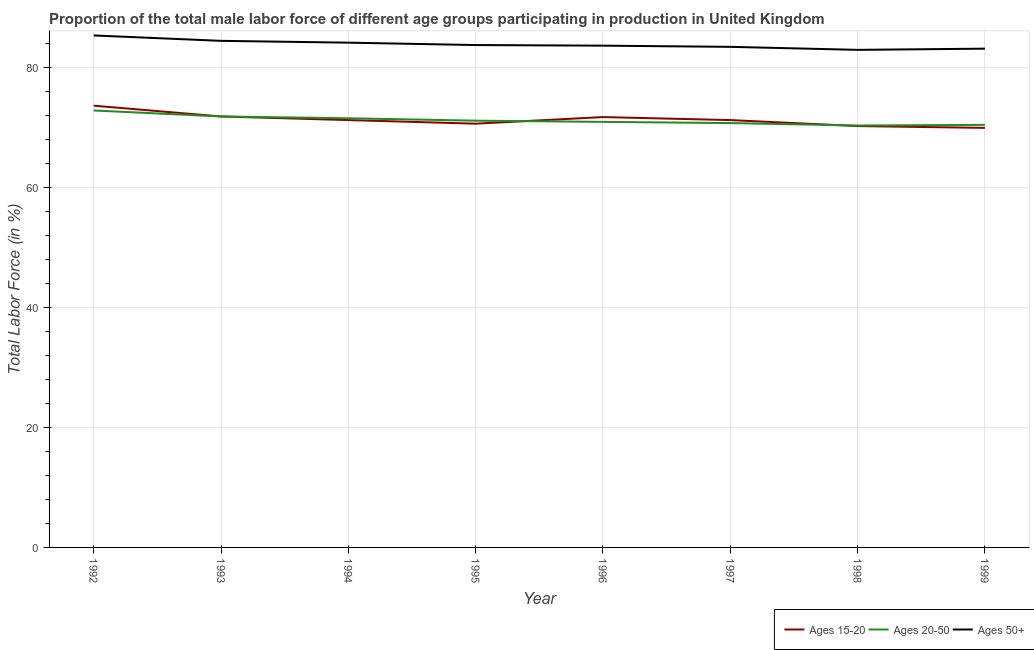Does the line corresponding to percentage of male labor force within the age group 20-50 intersect with the line corresponding to percentage of male labor force above age 50?
Your answer should be compact. No. Is the number of lines equal to the number of legend labels?
Make the answer very short. Yes. What is the percentage of male labor force above age 50 in 1994?
Your answer should be very brief. 84.1. Across all years, what is the maximum percentage of male labor force within the age group 20-50?
Your answer should be compact. 72.8. Across all years, what is the minimum percentage of male labor force within the age group 15-20?
Make the answer very short. 69.9. In which year was the percentage of male labor force above age 50 maximum?
Give a very brief answer. 1992. In which year was the percentage of male labor force above age 50 minimum?
Your response must be concise. 1998. What is the total percentage of male labor force above age 50 in the graph?
Ensure brevity in your answer.  670.5. What is the difference between the percentage of male labor force above age 50 in 1996 and that in 1998?
Provide a short and direct response. 0.7. What is the average percentage of male labor force within the age group 15-20 per year?
Your answer should be compact. 71.27. In the year 1993, what is the difference between the percentage of male labor force within the age group 15-20 and percentage of male labor force above age 50?
Provide a short and direct response. -12.6. In how many years, is the percentage of male labor force within the age group 20-50 greater than 16 %?
Give a very brief answer. 8. What is the ratio of the percentage of male labor force within the age group 15-20 in 1996 to that in 1997?
Your answer should be compact. 1.01. Is the difference between the percentage of male labor force within the age group 20-50 in 1994 and 1995 greater than the difference between the percentage of male labor force within the age group 15-20 in 1994 and 1995?
Provide a succinct answer. No. What is the difference between the highest and the second highest percentage of male labor force within the age group 20-50?
Offer a terse response. 1. What is the difference between the highest and the lowest percentage of male labor force within the age group 15-20?
Offer a very short reply. 3.7. How many lines are there?
Offer a terse response. 3. How many years are there in the graph?
Offer a terse response. 8. What is the difference between two consecutive major ticks on the Y-axis?
Give a very brief answer. 20. Are the values on the major ticks of Y-axis written in scientific E-notation?
Make the answer very short. No. Does the graph contain grids?
Ensure brevity in your answer.  Yes. How many legend labels are there?
Your response must be concise. 3. How are the legend labels stacked?
Ensure brevity in your answer.  Horizontal. What is the title of the graph?
Ensure brevity in your answer.  Proportion of the total male labor force of different age groups participating in production in United Kingdom. What is the Total Labor Force (in %) of Ages 15-20 in 1992?
Your answer should be compact. 73.6. What is the Total Labor Force (in %) of Ages 20-50 in 1992?
Your response must be concise. 72.8. What is the Total Labor Force (in %) in Ages 50+ in 1992?
Your answer should be compact. 85.3. What is the Total Labor Force (in %) in Ages 15-20 in 1993?
Your answer should be compact. 71.8. What is the Total Labor Force (in %) in Ages 20-50 in 1993?
Offer a terse response. 71.8. What is the Total Labor Force (in %) of Ages 50+ in 1993?
Your answer should be very brief. 84.4. What is the Total Labor Force (in %) in Ages 15-20 in 1994?
Make the answer very short. 71.2. What is the Total Labor Force (in %) in Ages 20-50 in 1994?
Your answer should be compact. 71.5. What is the Total Labor Force (in %) of Ages 50+ in 1994?
Your answer should be very brief. 84.1. What is the Total Labor Force (in %) of Ages 15-20 in 1995?
Provide a succinct answer. 70.6. What is the Total Labor Force (in %) of Ages 20-50 in 1995?
Provide a succinct answer. 71.1. What is the Total Labor Force (in %) of Ages 50+ in 1995?
Ensure brevity in your answer.  83.7. What is the Total Labor Force (in %) of Ages 15-20 in 1996?
Make the answer very short. 71.7. What is the Total Labor Force (in %) of Ages 20-50 in 1996?
Offer a terse response. 70.9. What is the Total Labor Force (in %) in Ages 50+ in 1996?
Your answer should be compact. 83.6. What is the Total Labor Force (in %) of Ages 15-20 in 1997?
Ensure brevity in your answer.  71.2. What is the Total Labor Force (in %) in Ages 20-50 in 1997?
Give a very brief answer. 70.7. What is the Total Labor Force (in %) of Ages 50+ in 1997?
Ensure brevity in your answer.  83.4. What is the Total Labor Force (in %) in Ages 15-20 in 1998?
Provide a short and direct response. 70.2. What is the Total Labor Force (in %) in Ages 20-50 in 1998?
Provide a succinct answer. 70.3. What is the Total Labor Force (in %) in Ages 50+ in 1998?
Provide a short and direct response. 82.9. What is the Total Labor Force (in %) of Ages 15-20 in 1999?
Your answer should be compact. 69.9. What is the Total Labor Force (in %) in Ages 20-50 in 1999?
Keep it short and to the point. 70.4. What is the Total Labor Force (in %) in Ages 50+ in 1999?
Give a very brief answer. 83.1. Across all years, what is the maximum Total Labor Force (in %) of Ages 15-20?
Give a very brief answer. 73.6. Across all years, what is the maximum Total Labor Force (in %) in Ages 20-50?
Make the answer very short. 72.8. Across all years, what is the maximum Total Labor Force (in %) of Ages 50+?
Offer a very short reply. 85.3. Across all years, what is the minimum Total Labor Force (in %) of Ages 15-20?
Offer a very short reply. 69.9. Across all years, what is the minimum Total Labor Force (in %) in Ages 20-50?
Your response must be concise. 70.3. Across all years, what is the minimum Total Labor Force (in %) in Ages 50+?
Provide a succinct answer. 82.9. What is the total Total Labor Force (in %) in Ages 15-20 in the graph?
Make the answer very short. 570.2. What is the total Total Labor Force (in %) in Ages 20-50 in the graph?
Offer a very short reply. 569.5. What is the total Total Labor Force (in %) in Ages 50+ in the graph?
Give a very brief answer. 670.5. What is the difference between the Total Labor Force (in %) in Ages 20-50 in 1992 and that in 1993?
Keep it short and to the point. 1. What is the difference between the Total Labor Force (in %) in Ages 50+ in 1992 and that in 1993?
Your answer should be very brief. 0.9. What is the difference between the Total Labor Force (in %) of Ages 15-20 in 1992 and that in 1994?
Make the answer very short. 2.4. What is the difference between the Total Labor Force (in %) of Ages 15-20 in 1992 and that in 1995?
Offer a very short reply. 3. What is the difference between the Total Labor Force (in %) of Ages 20-50 in 1992 and that in 1995?
Ensure brevity in your answer.  1.7. What is the difference between the Total Labor Force (in %) of Ages 50+ in 1992 and that in 1995?
Offer a terse response. 1.6. What is the difference between the Total Labor Force (in %) in Ages 15-20 in 1992 and that in 1996?
Offer a very short reply. 1.9. What is the difference between the Total Labor Force (in %) of Ages 20-50 in 1992 and that in 1996?
Ensure brevity in your answer.  1.9. What is the difference between the Total Labor Force (in %) in Ages 50+ in 1992 and that in 1996?
Make the answer very short. 1.7. What is the difference between the Total Labor Force (in %) of Ages 20-50 in 1992 and that in 1997?
Your answer should be very brief. 2.1. What is the difference between the Total Labor Force (in %) in Ages 50+ in 1992 and that in 1997?
Provide a succinct answer. 1.9. What is the difference between the Total Labor Force (in %) in Ages 15-20 in 1992 and that in 1998?
Ensure brevity in your answer.  3.4. What is the difference between the Total Labor Force (in %) of Ages 20-50 in 1992 and that in 1998?
Offer a very short reply. 2.5. What is the difference between the Total Labor Force (in %) in Ages 15-20 in 1992 and that in 1999?
Ensure brevity in your answer.  3.7. What is the difference between the Total Labor Force (in %) in Ages 50+ in 1993 and that in 1994?
Offer a very short reply. 0.3. What is the difference between the Total Labor Force (in %) of Ages 20-50 in 1993 and that in 1996?
Provide a succinct answer. 0.9. What is the difference between the Total Labor Force (in %) in Ages 50+ in 1993 and that in 1996?
Offer a terse response. 0.8. What is the difference between the Total Labor Force (in %) in Ages 15-20 in 1993 and that in 1997?
Make the answer very short. 0.6. What is the difference between the Total Labor Force (in %) in Ages 20-50 in 1993 and that in 1998?
Offer a very short reply. 1.5. What is the difference between the Total Labor Force (in %) in Ages 50+ in 1993 and that in 1998?
Your response must be concise. 1.5. What is the difference between the Total Labor Force (in %) of Ages 50+ in 1993 and that in 1999?
Give a very brief answer. 1.3. What is the difference between the Total Labor Force (in %) in Ages 15-20 in 1994 and that in 1995?
Your response must be concise. 0.6. What is the difference between the Total Labor Force (in %) in Ages 15-20 in 1994 and that in 1996?
Ensure brevity in your answer.  -0.5. What is the difference between the Total Labor Force (in %) of Ages 20-50 in 1994 and that in 1996?
Your answer should be very brief. 0.6. What is the difference between the Total Labor Force (in %) of Ages 15-20 in 1994 and that in 1997?
Make the answer very short. 0. What is the difference between the Total Labor Force (in %) in Ages 15-20 in 1994 and that in 1998?
Offer a terse response. 1. What is the difference between the Total Labor Force (in %) in Ages 20-50 in 1994 and that in 1998?
Offer a very short reply. 1.2. What is the difference between the Total Labor Force (in %) of Ages 50+ in 1994 and that in 1998?
Offer a very short reply. 1.2. What is the difference between the Total Labor Force (in %) of Ages 15-20 in 1994 and that in 1999?
Your response must be concise. 1.3. What is the difference between the Total Labor Force (in %) of Ages 50+ in 1994 and that in 1999?
Your answer should be very brief. 1. What is the difference between the Total Labor Force (in %) in Ages 15-20 in 1995 and that in 1997?
Offer a terse response. -0.6. What is the difference between the Total Labor Force (in %) of Ages 50+ in 1995 and that in 1998?
Your answer should be very brief. 0.8. What is the difference between the Total Labor Force (in %) in Ages 15-20 in 1996 and that in 1997?
Offer a terse response. 0.5. What is the difference between the Total Labor Force (in %) in Ages 15-20 in 1996 and that in 1998?
Offer a terse response. 1.5. What is the difference between the Total Labor Force (in %) in Ages 20-50 in 1996 and that in 1998?
Ensure brevity in your answer.  0.6. What is the difference between the Total Labor Force (in %) of Ages 15-20 in 1997 and that in 1998?
Provide a succinct answer. 1. What is the difference between the Total Labor Force (in %) of Ages 20-50 in 1997 and that in 1999?
Give a very brief answer. 0.3. What is the difference between the Total Labor Force (in %) in Ages 50+ in 1997 and that in 1999?
Your response must be concise. 0.3. What is the difference between the Total Labor Force (in %) of Ages 15-20 in 1998 and that in 1999?
Give a very brief answer. 0.3. What is the difference between the Total Labor Force (in %) in Ages 20-50 in 1998 and that in 1999?
Offer a very short reply. -0.1. What is the difference between the Total Labor Force (in %) of Ages 50+ in 1998 and that in 1999?
Give a very brief answer. -0.2. What is the difference between the Total Labor Force (in %) of Ages 15-20 in 1992 and the Total Labor Force (in %) of Ages 50+ in 1993?
Offer a very short reply. -10.8. What is the difference between the Total Labor Force (in %) in Ages 15-20 in 1992 and the Total Labor Force (in %) in Ages 20-50 in 1994?
Your response must be concise. 2.1. What is the difference between the Total Labor Force (in %) in Ages 20-50 in 1992 and the Total Labor Force (in %) in Ages 50+ in 1994?
Offer a terse response. -11.3. What is the difference between the Total Labor Force (in %) in Ages 20-50 in 1992 and the Total Labor Force (in %) in Ages 50+ in 1995?
Ensure brevity in your answer.  -10.9. What is the difference between the Total Labor Force (in %) in Ages 15-20 in 1992 and the Total Labor Force (in %) in Ages 20-50 in 1996?
Your answer should be very brief. 2.7. What is the difference between the Total Labor Force (in %) in Ages 20-50 in 1992 and the Total Labor Force (in %) in Ages 50+ in 1996?
Make the answer very short. -10.8. What is the difference between the Total Labor Force (in %) of Ages 15-20 in 1992 and the Total Labor Force (in %) of Ages 20-50 in 1997?
Offer a terse response. 2.9. What is the difference between the Total Labor Force (in %) in Ages 15-20 in 1992 and the Total Labor Force (in %) in Ages 50+ in 1997?
Your answer should be compact. -9.8. What is the difference between the Total Labor Force (in %) in Ages 20-50 in 1992 and the Total Labor Force (in %) in Ages 50+ in 1997?
Offer a terse response. -10.6. What is the difference between the Total Labor Force (in %) in Ages 15-20 in 1992 and the Total Labor Force (in %) in Ages 20-50 in 1998?
Give a very brief answer. 3.3. What is the difference between the Total Labor Force (in %) of Ages 15-20 in 1992 and the Total Labor Force (in %) of Ages 20-50 in 1999?
Give a very brief answer. 3.2. What is the difference between the Total Labor Force (in %) of Ages 15-20 in 1992 and the Total Labor Force (in %) of Ages 50+ in 1999?
Ensure brevity in your answer.  -9.5. What is the difference between the Total Labor Force (in %) in Ages 15-20 in 1993 and the Total Labor Force (in %) in Ages 50+ in 1994?
Your answer should be compact. -12.3. What is the difference between the Total Labor Force (in %) in Ages 20-50 in 1993 and the Total Labor Force (in %) in Ages 50+ in 1995?
Your answer should be compact. -11.9. What is the difference between the Total Labor Force (in %) of Ages 15-20 in 1993 and the Total Labor Force (in %) of Ages 20-50 in 1996?
Your answer should be very brief. 0.9. What is the difference between the Total Labor Force (in %) of Ages 15-20 in 1993 and the Total Labor Force (in %) of Ages 50+ in 1996?
Make the answer very short. -11.8. What is the difference between the Total Labor Force (in %) in Ages 15-20 in 1993 and the Total Labor Force (in %) in Ages 50+ in 1998?
Make the answer very short. -11.1. What is the difference between the Total Labor Force (in %) in Ages 15-20 in 1993 and the Total Labor Force (in %) in Ages 50+ in 1999?
Your answer should be compact. -11.3. What is the difference between the Total Labor Force (in %) of Ages 15-20 in 1994 and the Total Labor Force (in %) of Ages 50+ in 1995?
Give a very brief answer. -12.5. What is the difference between the Total Labor Force (in %) in Ages 20-50 in 1994 and the Total Labor Force (in %) in Ages 50+ in 1995?
Offer a terse response. -12.2. What is the difference between the Total Labor Force (in %) in Ages 15-20 in 1994 and the Total Labor Force (in %) in Ages 50+ in 1996?
Your response must be concise. -12.4. What is the difference between the Total Labor Force (in %) in Ages 20-50 in 1994 and the Total Labor Force (in %) in Ages 50+ in 1996?
Provide a succinct answer. -12.1. What is the difference between the Total Labor Force (in %) in Ages 15-20 in 1994 and the Total Labor Force (in %) in Ages 20-50 in 1997?
Your response must be concise. 0.5. What is the difference between the Total Labor Force (in %) of Ages 15-20 in 1994 and the Total Labor Force (in %) of Ages 50+ in 1998?
Offer a terse response. -11.7. What is the difference between the Total Labor Force (in %) of Ages 20-50 in 1994 and the Total Labor Force (in %) of Ages 50+ in 1998?
Offer a very short reply. -11.4. What is the difference between the Total Labor Force (in %) of Ages 15-20 in 1995 and the Total Labor Force (in %) of Ages 20-50 in 1996?
Offer a very short reply. -0.3. What is the difference between the Total Labor Force (in %) of Ages 15-20 in 1995 and the Total Labor Force (in %) of Ages 20-50 in 1997?
Offer a very short reply. -0.1. What is the difference between the Total Labor Force (in %) in Ages 15-20 in 1995 and the Total Labor Force (in %) in Ages 20-50 in 1998?
Keep it short and to the point. 0.3. What is the difference between the Total Labor Force (in %) of Ages 20-50 in 1995 and the Total Labor Force (in %) of Ages 50+ in 1999?
Make the answer very short. -12. What is the difference between the Total Labor Force (in %) in Ages 20-50 in 1996 and the Total Labor Force (in %) in Ages 50+ in 1998?
Your response must be concise. -12. What is the difference between the Total Labor Force (in %) in Ages 15-20 in 1996 and the Total Labor Force (in %) in Ages 20-50 in 1999?
Your answer should be compact. 1.3. What is the difference between the Total Labor Force (in %) of Ages 20-50 in 1997 and the Total Labor Force (in %) of Ages 50+ in 1998?
Your answer should be compact. -12.2. What is the difference between the Total Labor Force (in %) of Ages 15-20 in 1997 and the Total Labor Force (in %) of Ages 20-50 in 1999?
Offer a very short reply. 0.8. What is the difference between the Total Labor Force (in %) in Ages 20-50 in 1997 and the Total Labor Force (in %) in Ages 50+ in 1999?
Ensure brevity in your answer.  -12.4. What is the difference between the Total Labor Force (in %) of Ages 15-20 in 1998 and the Total Labor Force (in %) of Ages 20-50 in 1999?
Keep it short and to the point. -0.2. What is the difference between the Total Labor Force (in %) in Ages 15-20 in 1998 and the Total Labor Force (in %) in Ages 50+ in 1999?
Your response must be concise. -12.9. What is the difference between the Total Labor Force (in %) in Ages 20-50 in 1998 and the Total Labor Force (in %) in Ages 50+ in 1999?
Offer a terse response. -12.8. What is the average Total Labor Force (in %) of Ages 15-20 per year?
Provide a succinct answer. 71.28. What is the average Total Labor Force (in %) of Ages 20-50 per year?
Offer a terse response. 71.19. What is the average Total Labor Force (in %) in Ages 50+ per year?
Make the answer very short. 83.81. In the year 1992, what is the difference between the Total Labor Force (in %) in Ages 15-20 and Total Labor Force (in %) in Ages 50+?
Your answer should be very brief. -11.7. In the year 1992, what is the difference between the Total Labor Force (in %) of Ages 20-50 and Total Labor Force (in %) of Ages 50+?
Provide a short and direct response. -12.5. In the year 1993, what is the difference between the Total Labor Force (in %) in Ages 15-20 and Total Labor Force (in %) in Ages 20-50?
Your response must be concise. 0. In the year 1994, what is the difference between the Total Labor Force (in %) of Ages 15-20 and Total Labor Force (in %) of Ages 50+?
Offer a very short reply. -12.9. In the year 1995, what is the difference between the Total Labor Force (in %) of Ages 15-20 and Total Labor Force (in %) of Ages 50+?
Make the answer very short. -13.1. In the year 1996, what is the difference between the Total Labor Force (in %) in Ages 15-20 and Total Labor Force (in %) in Ages 50+?
Ensure brevity in your answer.  -11.9. In the year 1997, what is the difference between the Total Labor Force (in %) of Ages 15-20 and Total Labor Force (in %) of Ages 50+?
Provide a short and direct response. -12.2. In the year 1997, what is the difference between the Total Labor Force (in %) in Ages 20-50 and Total Labor Force (in %) in Ages 50+?
Give a very brief answer. -12.7. In the year 1998, what is the difference between the Total Labor Force (in %) of Ages 15-20 and Total Labor Force (in %) of Ages 50+?
Ensure brevity in your answer.  -12.7. In the year 1999, what is the difference between the Total Labor Force (in %) in Ages 15-20 and Total Labor Force (in %) in Ages 20-50?
Ensure brevity in your answer.  -0.5. In the year 1999, what is the difference between the Total Labor Force (in %) in Ages 15-20 and Total Labor Force (in %) in Ages 50+?
Offer a very short reply. -13.2. What is the ratio of the Total Labor Force (in %) of Ages 15-20 in 1992 to that in 1993?
Offer a very short reply. 1.03. What is the ratio of the Total Labor Force (in %) in Ages 20-50 in 1992 to that in 1993?
Offer a terse response. 1.01. What is the ratio of the Total Labor Force (in %) of Ages 50+ in 1992 to that in 1993?
Your answer should be very brief. 1.01. What is the ratio of the Total Labor Force (in %) in Ages 15-20 in 1992 to that in 1994?
Make the answer very short. 1.03. What is the ratio of the Total Labor Force (in %) of Ages 20-50 in 1992 to that in 1994?
Provide a short and direct response. 1.02. What is the ratio of the Total Labor Force (in %) in Ages 50+ in 1992 to that in 1994?
Make the answer very short. 1.01. What is the ratio of the Total Labor Force (in %) in Ages 15-20 in 1992 to that in 1995?
Keep it short and to the point. 1.04. What is the ratio of the Total Labor Force (in %) in Ages 20-50 in 1992 to that in 1995?
Your response must be concise. 1.02. What is the ratio of the Total Labor Force (in %) of Ages 50+ in 1992 to that in 1995?
Your answer should be very brief. 1.02. What is the ratio of the Total Labor Force (in %) in Ages 15-20 in 1992 to that in 1996?
Offer a very short reply. 1.03. What is the ratio of the Total Labor Force (in %) in Ages 20-50 in 1992 to that in 1996?
Make the answer very short. 1.03. What is the ratio of the Total Labor Force (in %) of Ages 50+ in 1992 to that in 1996?
Provide a short and direct response. 1.02. What is the ratio of the Total Labor Force (in %) in Ages 15-20 in 1992 to that in 1997?
Offer a very short reply. 1.03. What is the ratio of the Total Labor Force (in %) of Ages 20-50 in 1992 to that in 1997?
Give a very brief answer. 1.03. What is the ratio of the Total Labor Force (in %) in Ages 50+ in 1992 to that in 1997?
Keep it short and to the point. 1.02. What is the ratio of the Total Labor Force (in %) in Ages 15-20 in 1992 to that in 1998?
Give a very brief answer. 1.05. What is the ratio of the Total Labor Force (in %) of Ages 20-50 in 1992 to that in 1998?
Ensure brevity in your answer.  1.04. What is the ratio of the Total Labor Force (in %) of Ages 50+ in 1992 to that in 1998?
Provide a succinct answer. 1.03. What is the ratio of the Total Labor Force (in %) of Ages 15-20 in 1992 to that in 1999?
Your response must be concise. 1.05. What is the ratio of the Total Labor Force (in %) of Ages 20-50 in 1992 to that in 1999?
Your response must be concise. 1.03. What is the ratio of the Total Labor Force (in %) in Ages 50+ in 1992 to that in 1999?
Ensure brevity in your answer.  1.03. What is the ratio of the Total Labor Force (in %) of Ages 15-20 in 1993 to that in 1994?
Offer a terse response. 1.01. What is the ratio of the Total Labor Force (in %) of Ages 20-50 in 1993 to that in 1995?
Give a very brief answer. 1.01. What is the ratio of the Total Labor Force (in %) in Ages 50+ in 1993 to that in 1995?
Give a very brief answer. 1.01. What is the ratio of the Total Labor Force (in %) in Ages 20-50 in 1993 to that in 1996?
Provide a short and direct response. 1.01. What is the ratio of the Total Labor Force (in %) in Ages 50+ in 1993 to that in 1996?
Give a very brief answer. 1.01. What is the ratio of the Total Labor Force (in %) in Ages 15-20 in 1993 to that in 1997?
Give a very brief answer. 1.01. What is the ratio of the Total Labor Force (in %) in Ages 20-50 in 1993 to that in 1997?
Your answer should be compact. 1.02. What is the ratio of the Total Labor Force (in %) of Ages 50+ in 1993 to that in 1997?
Keep it short and to the point. 1.01. What is the ratio of the Total Labor Force (in %) in Ages 15-20 in 1993 to that in 1998?
Your answer should be compact. 1.02. What is the ratio of the Total Labor Force (in %) in Ages 20-50 in 1993 to that in 1998?
Offer a very short reply. 1.02. What is the ratio of the Total Labor Force (in %) in Ages 50+ in 1993 to that in 1998?
Ensure brevity in your answer.  1.02. What is the ratio of the Total Labor Force (in %) of Ages 15-20 in 1993 to that in 1999?
Offer a terse response. 1.03. What is the ratio of the Total Labor Force (in %) in Ages 20-50 in 1993 to that in 1999?
Your answer should be very brief. 1.02. What is the ratio of the Total Labor Force (in %) of Ages 50+ in 1993 to that in 1999?
Provide a short and direct response. 1.02. What is the ratio of the Total Labor Force (in %) in Ages 15-20 in 1994 to that in 1995?
Provide a short and direct response. 1.01. What is the ratio of the Total Labor Force (in %) of Ages 20-50 in 1994 to that in 1995?
Your response must be concise. 1.01. What is the ratio of the Total Labor Force (in %) of Ages 15-20 in 1994 to that in 1996?
Give a very brief answer. 0.99. What is the ratio of the Total Labor Force (in %) in Ages 20-50 in 1994 to that in 1996?
Offer a very short reply. 1.01. What is the ratio of the Total Labor Force (in %) of Ages 20-50 in 1994 to that in 1997?
Provide a succinct answer. 1.01. What is the ratio of the Total Labor Force (in %) of Ages 50+ in 1994 to that in 1997?
Provide a short and direct response. 1.01. What is the ratio of the Total Labor Force (in %) in Ages 15-20 in 1994 to that in 1998?
Your answer should be very brief. 1.01. What is the ratio of the Total Labor Force (in %) in Ages 20-50 in 1994 to that in 1998?
Your answer should be very brief. 1.02. What is the ratio of the Total Labor Force (in %) of Ages 50+ in 1994 to that in 1998?
Your response must be concise. 1.01. What is the ratio of the Total Labor Force (in %) in Ages 15-20 in 1994 to that in 1999?
Your answer should be compact. 1.02. What is the ratio of the Total Labor Force (in %) of Ages 20-50 in 1994 to that in 1999?
Your response must be concise. 1.02. What is the ratio of the Total Labor Force (in %) in Ages 50+ in 1994 to that in 1999?
Your answer should be compact. 1.01. What is the ratio of the Total Labor Force (in %) in Ages 15-20 in 1995 to that in 1996?
Offer a very short reply. 0.98. What is the ratio of the Total Labor Force (in %) of Ages 50+ in 1995 to that in 1996?
Keep it short and to the point. 1. What is the ratio of the Total Labor Force (in %) of Ages 15-20 in 1995 to that in 1997?
Your response must be concise. 0.99. What is the ratio of the Total Labor Force (in %) of Ages 50+ in 1995 to that in 1997?
Give a very brief answer. 1. What is the ratio of the Total Labor Force (in %) of Ages 20-50 in 1995 to that in 1998?
Offer a terse response. 1.01. What is the ratio of the Total Labor Force (in %) of Ages 50+ in 1995 to that in 1998?
Offer a terse response. 1.01. What is the ratio of the Total Labor Force (in %) of Ages 15-20 in 1995 to that in 1999?
Ensure brevity in your answer.  1.01. What is the ratio of the Total Labor Force (in %) in Ages 20-50 in 1995 to that in 1999?
Make the answer very short. 1.01. What is the ratio of the Total Labor Force (in %) in Ages 50+ in 1995 to that in 1999?
Keep it short and to the point. 1.01. What is the ratio of the Total Labor Force (in %) of Ages 15-20 in 1996 to that in 1997?
Your response must be concise. 1.01. What is the ratio of the Total Labor Force (in %) of Ages 15-20 in 1996 to that in 1998?
Provide a succinct answer. 1.02. What is the ratio of the Total Labor Force (in %) of Ages 20-50 in 1996 to that in 1998?
Your answer should be very brief. 1.01. What is the ratio of the Total Labor Force (in %) in Ages 50+ in 1996 to that in 1998?
Ensure brevity in your answer.  1.01. What is the ratio of the Total Labor Force (in %) in Ages 15-20 in 1996 to that in 1999?
Make the answer very short. 1.03. What is the ratio of the Total Labor Force (in %) in Ages 20-50 in 1996 to that in 1999?
Offer a very short reply. 1.01. What is the ratio of the Total Labor Force (in %) of Ages 50+ in 1996 to that in 1999?
Provide a succinct answer. 1.01. What is the ratio of the Total Labor Force (in %) in Ages 15-20 in 1997 to that in 1998?
Provide a succinct answer. 1.01. What is the ratio of the Total Labor Force (in %) of Ages 20-50 in 1997 to that in 1998?
Offer a very short reply. 1.01. What is the ratio of the Total Labor Force (in %) in Ages 15-20 in 1997 to that in 1999?
Provide a short and direct response. 1.02. What is the ratio of the Total Labor Force (in %) in Ages 20-50 in 1997 to that in 1999?
Your response must be concise. 1. What is the ratio of the Total Labor Force (in %) in Ages 15-20 in 1998 to that in 1999?
Give a very brief answer. 1. What is the ratio of the Total Labor Force (in %) of Ages 20-50 in 1998 to that in 1999?
Make the answer very short. 1. What is the ratio of the Total Labor Force (in %) in Ages 50+ in 1998 to that in 1999?
Your answer should be compact. 1. What is the difference between the highest and the second highest Total Labor Force (in %) in Ages 20-50?
Your answer should be compact. 1. What is the difference between the highest and the lowest Total Labor Force (in %) in Ages 20-50?
Provide a short and direct response. 2.5. What is the difference between the highest and the lowest Total Labor Force (in %) in Ages 50+?
Your answer should be compact. 2.4. 